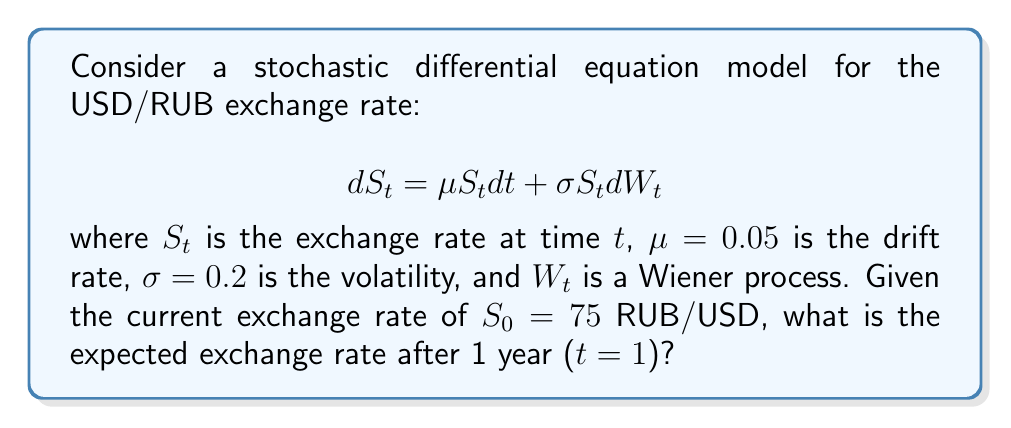Could you help me with this problem? To solve this problem, we'll follow these steps:

1) The stochastic differential equation given is for a geometric Brownian motion, which is commonly used to model exchange rates.

2) For a geometric Brownian motion, the expected value of $S_t$ is given by:

   $$E[S_t] = S_0 e^{\mu t}$$

3) We're given:
   - $S_0 = 75$ RUB/USD (initial exchange rate)
   - $\mu = 0.05$ (drift rate)
   - $t = 1$ year

4) Substituting these values into the formula:

   $$E[S_1] = 75 e^{0.05 * 1}$$

5) Calculating:
   
   $$E[S_1] = 75 e^{0.05} \approx 75 * 1.0513 \approx 78.85$$

Therefore, the expected exchange rate after 1 year is approximately 78.85 RUB/USD.
Answer: 78.85 RUB/USD 